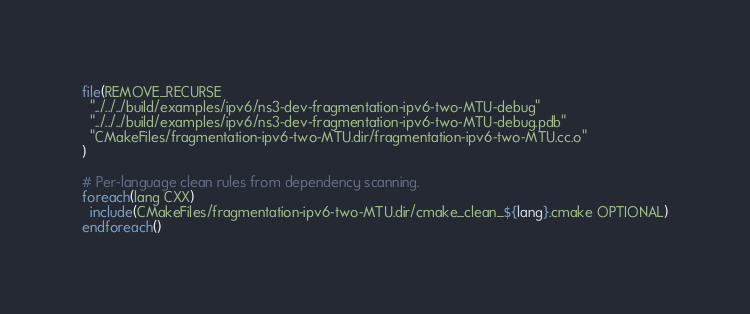Convert code to text. <code><loc_0><loc_0><loc_500><loc_500><_CMake_>file(REMOVE_RECURSE
  "../../../build/examples/ipv6/ns3-dev-fragmentation-ipv6-two-MTU-debug"
  "../../../build/examples/ipv6/ns3-dev-fragmentation-ipv6-two-MTU-debug.pdb"
  "CMakeFiles/fragmentation-ipv6-two-MTU.dir/fragmentation-ipv6-two-MTU.cc.o"
)

# Per-language clean rules from dependency scanning.
foreach(lang CXX)
  include(CMakeFiles/fragmentation-ipv6-two-MTU.dir/cmake_clean_${lang}.cmake OPTIONAL)
endforeach()
</code> 